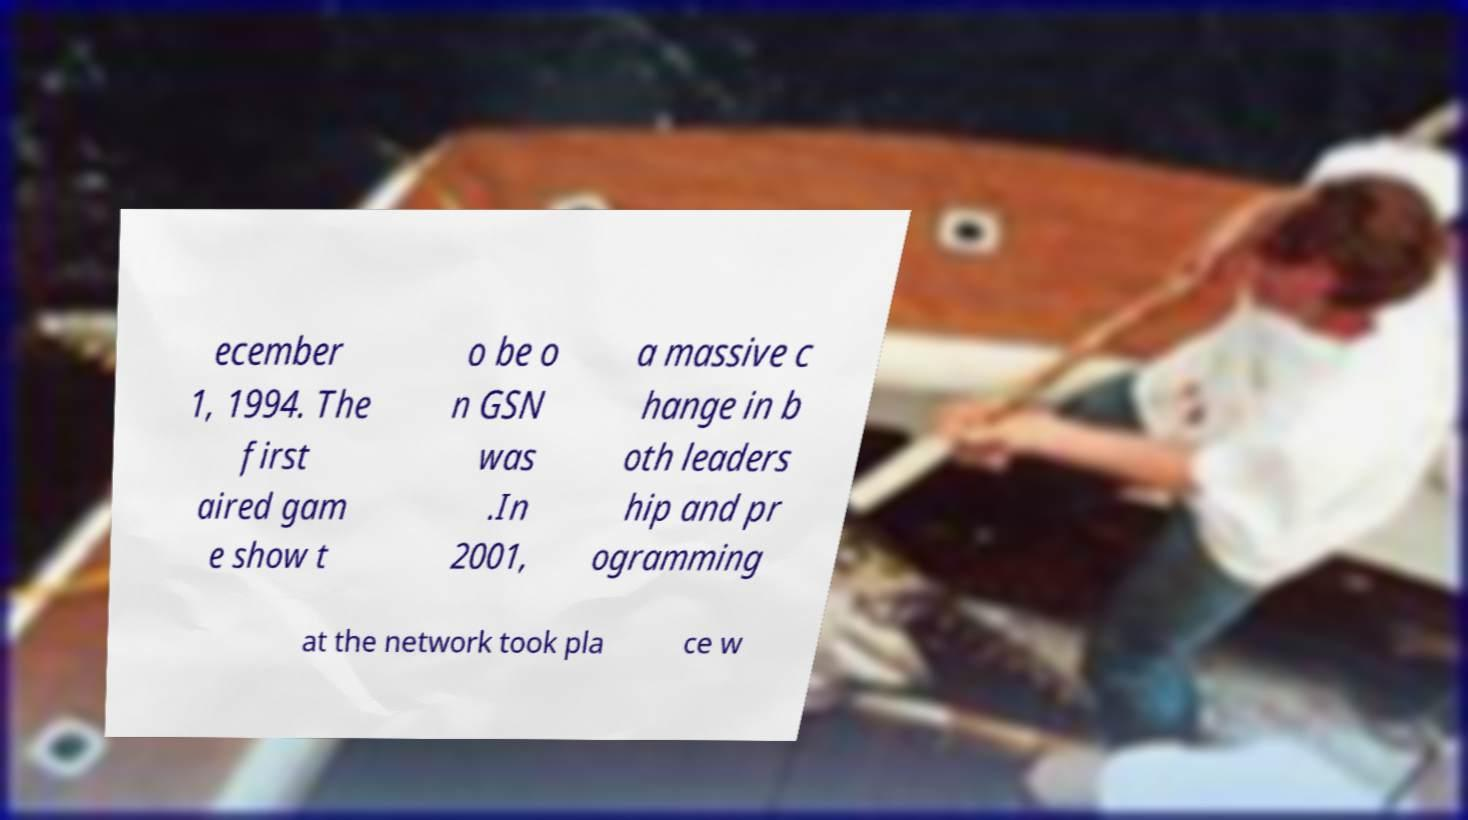Can you read and provide the text displayed in the image?This photo seems to have some interesting text. Can you extract and type it out for me? ecember 1, 1994. The first aired gam e show t o be o n GSN was .In 2001, a massive c hange in b oth leaders hip and pr ogramming at the network took pla ce w 